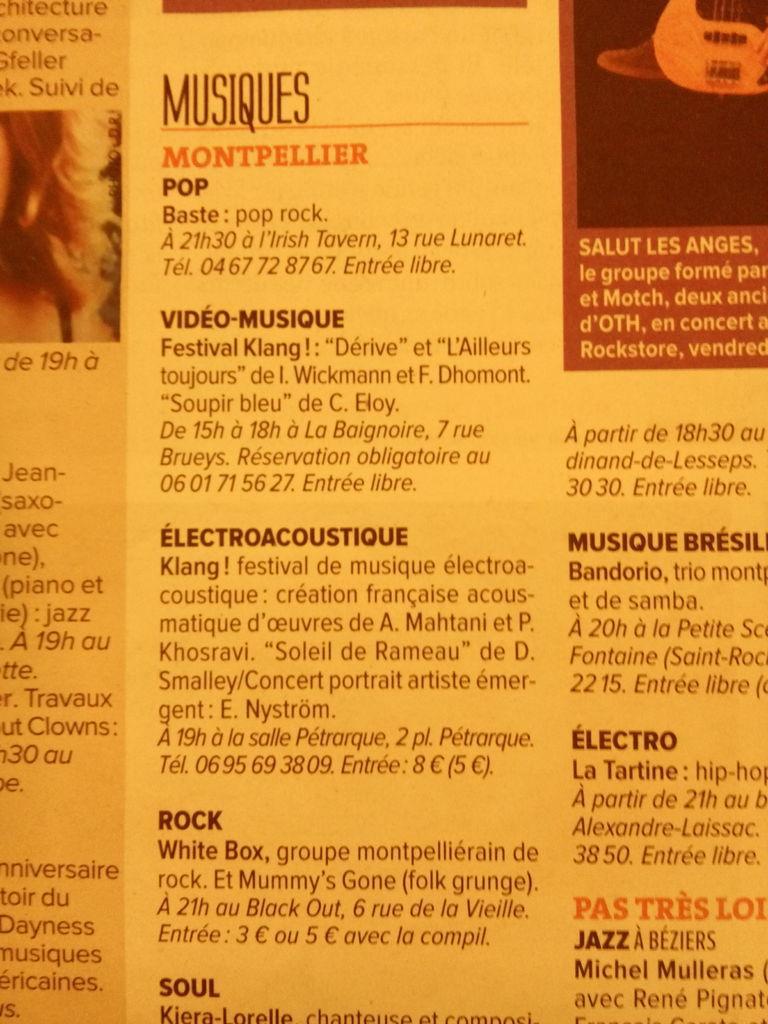Could you give a brief overview of what you see in this image? In this picture I can see a paper, there are numbers, words and photos on the paper. 